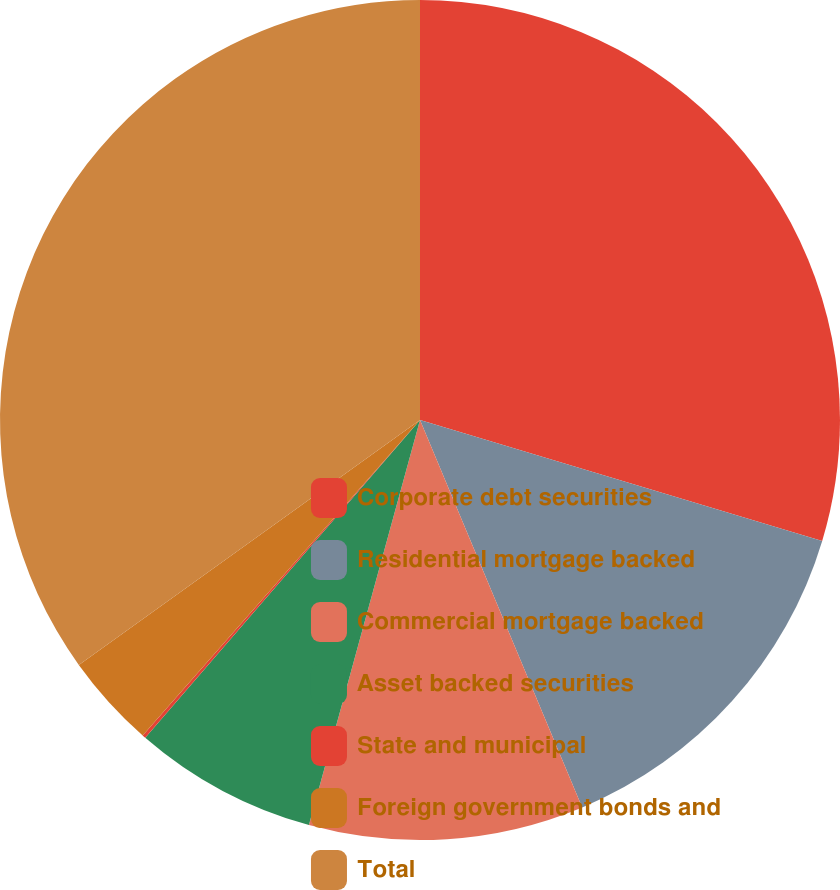<chart> <loc_0><loc_0><loc_500><loc_500><pie_chart><fcel>Corporate debt securities<fcel>Residential mortgage backed<fcel>Commercial mortgage backed<fcel>Asset backed securities<fcel>State and municipal<fcel>Foreign government bonds and<fcel>Total<nl><fcel>29.65%<fcel>14.04%<fcel>10.57%<fcel>7.09%<fcel>0.13%<fcel>3.61%<fcel>34.91%<nl></chart> 